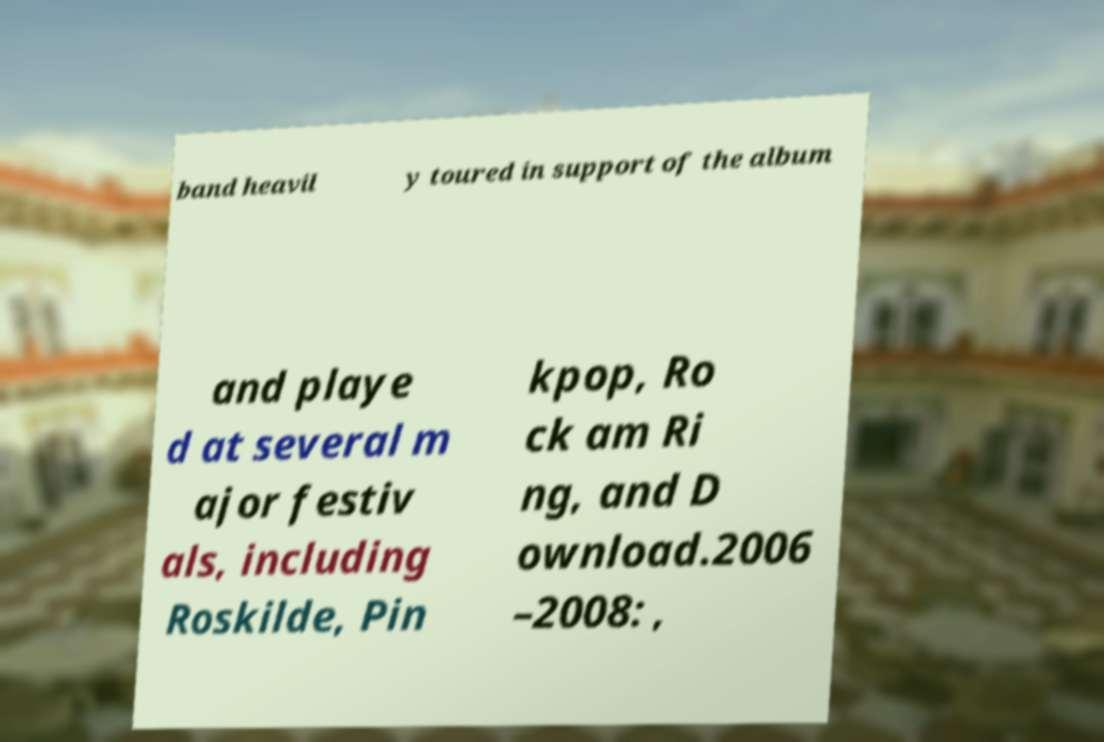Please read and relay the text visible in this image. What does it say? band heavil y toured in support of the album and playe d at several m ajor festiv als, including Roskilde, Pin kpop, Ro ck am Ri ng, and D ownload.2006 –2008: , 